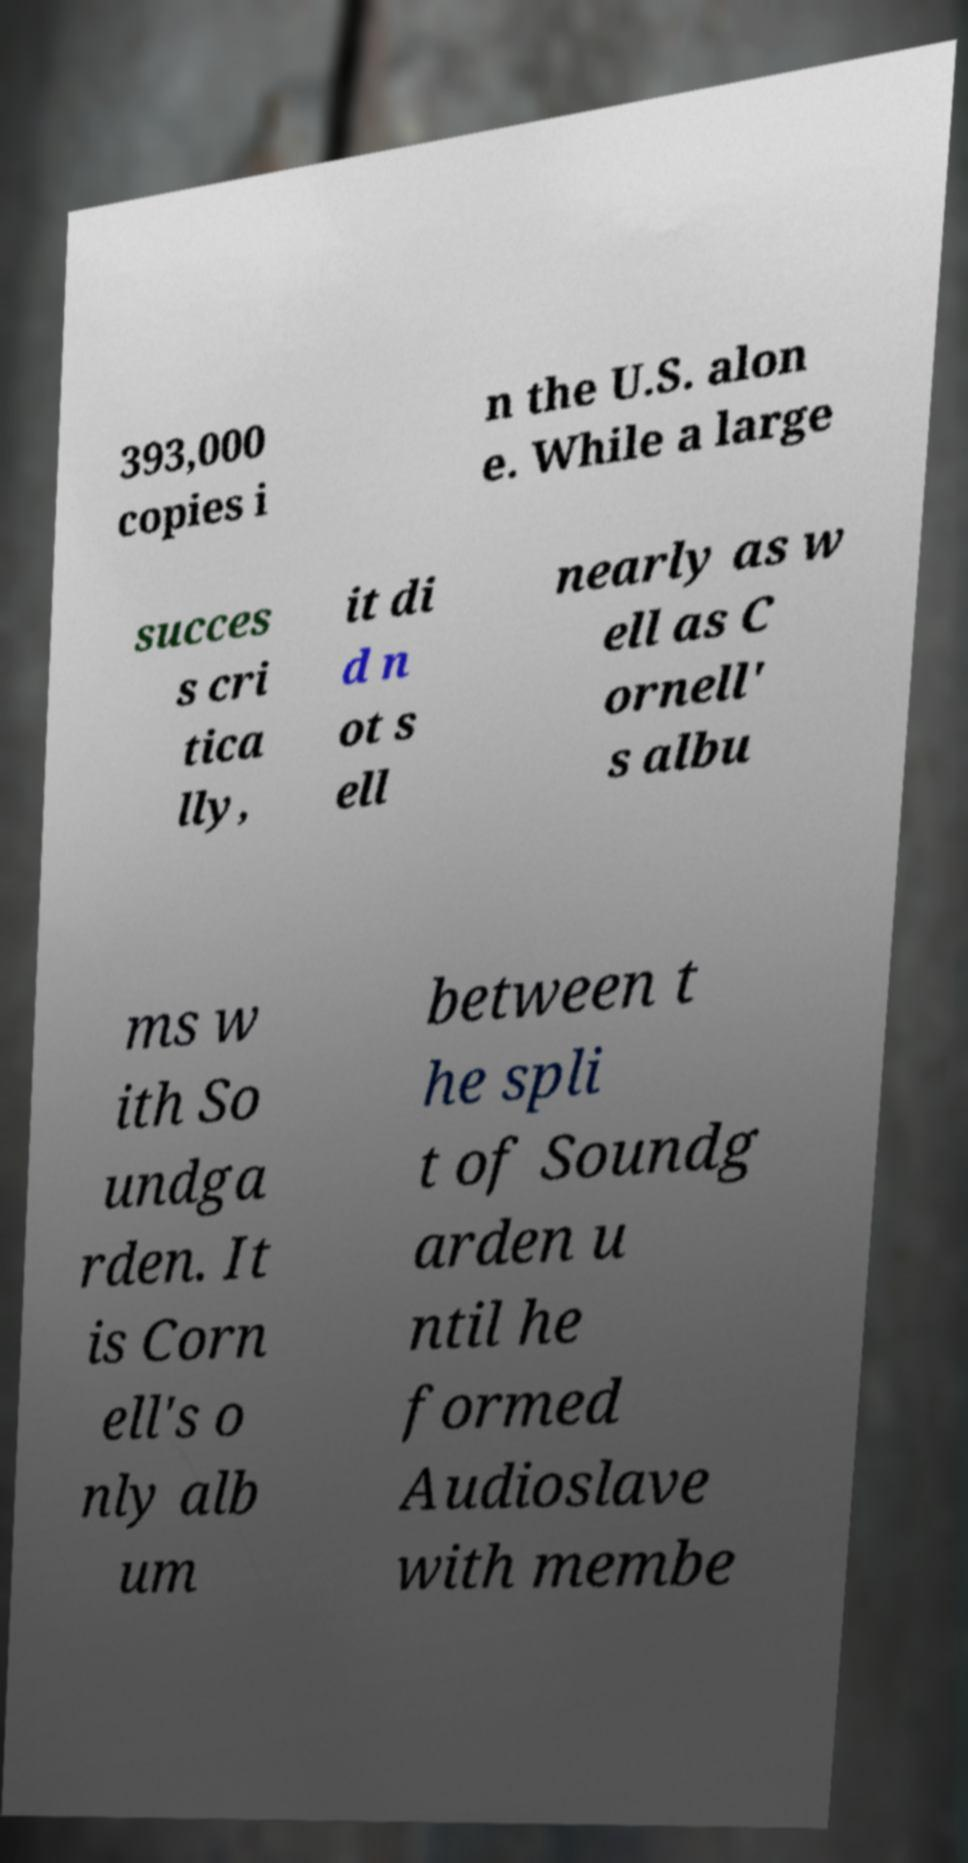Can you read and provide the text displayed in the image?This photo seems to have some interesting text. Can you extract and type it out for me? 393,000 copies i n the U.S. alon e. While a large succes s cri tica lly, it di d n ot s ell nearly as w ell as C ornell' s albu ms w ith So undga rden. It is Corn ell's o nly alb um between t he spli t of Soundg arden u ntil he formed Audioslave with membe 